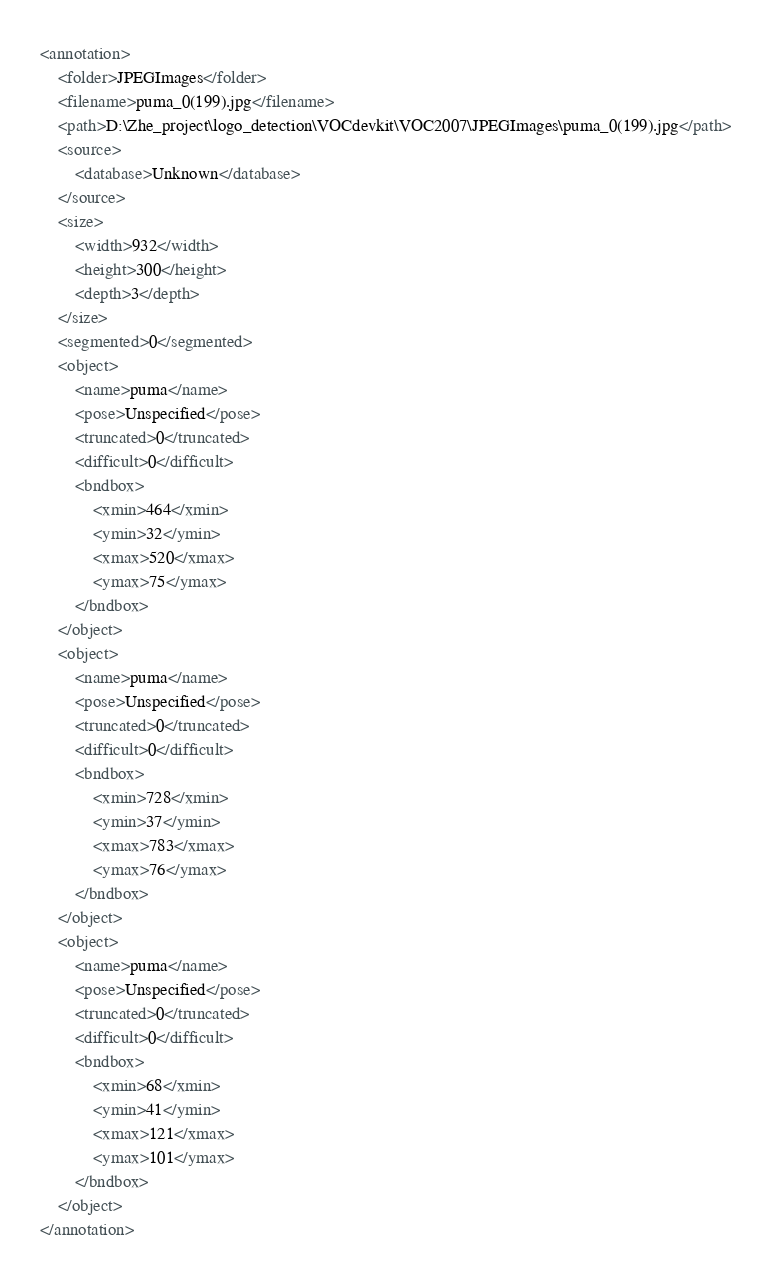Convert code to text. <code><loc_0><loc_0><loc_500><loc_500><_XML_><annotation>
	<folder>JPEGImages</folder>
	<filename>puma_0(199).jpg</filename>
	<path>D:\Zhe_project\logo_detection\VOCdevkit\VOC2007\JPEGImages\puma_0(199).jpg</path>
	<source>
		<database>Unknown</database>
	</source>
	<size>
		<width>932</width>
		<height>300</height>
		<depth>3</depth>
	</size>
	<segmented>0</segmented>
	<object>
		<name>puma</name>
		<pose>Unspecified</pose>
		<truncated>0</truncated>
		<difficult>0</difficult>
		<bndbox>
			<xmin>464</xmin>
			<ymin>32</ymin>
			<xmax>520</xmax>
			<ymax>75</ymax>
		</bndbox>
	</object>
	<object>
		<name>puma</name>
		<pose>Unspecified</pose>
		<truncated>0</truncated>
		<difficult>0</difficult>
		<bndbox>
			<xmin>728</xmin>
			<ymin>37</ymin>
			<xmax>783</xmax>
			<ymax>76</ymax>
		</bndbox>
	</object>
	<object>
		<name>puma</name>
		<pose>Unspecified</pose>
		<truncated>0</truncated>
		<difficult>0</difficult>
		<bndbox>
			<xmin>68</xmin>
			<ymin>41</ymin>
			<xmax>121</xmax>
			<ymax>101</ymax>
		</bndbox>
	</object>
</annotation>
</code> 